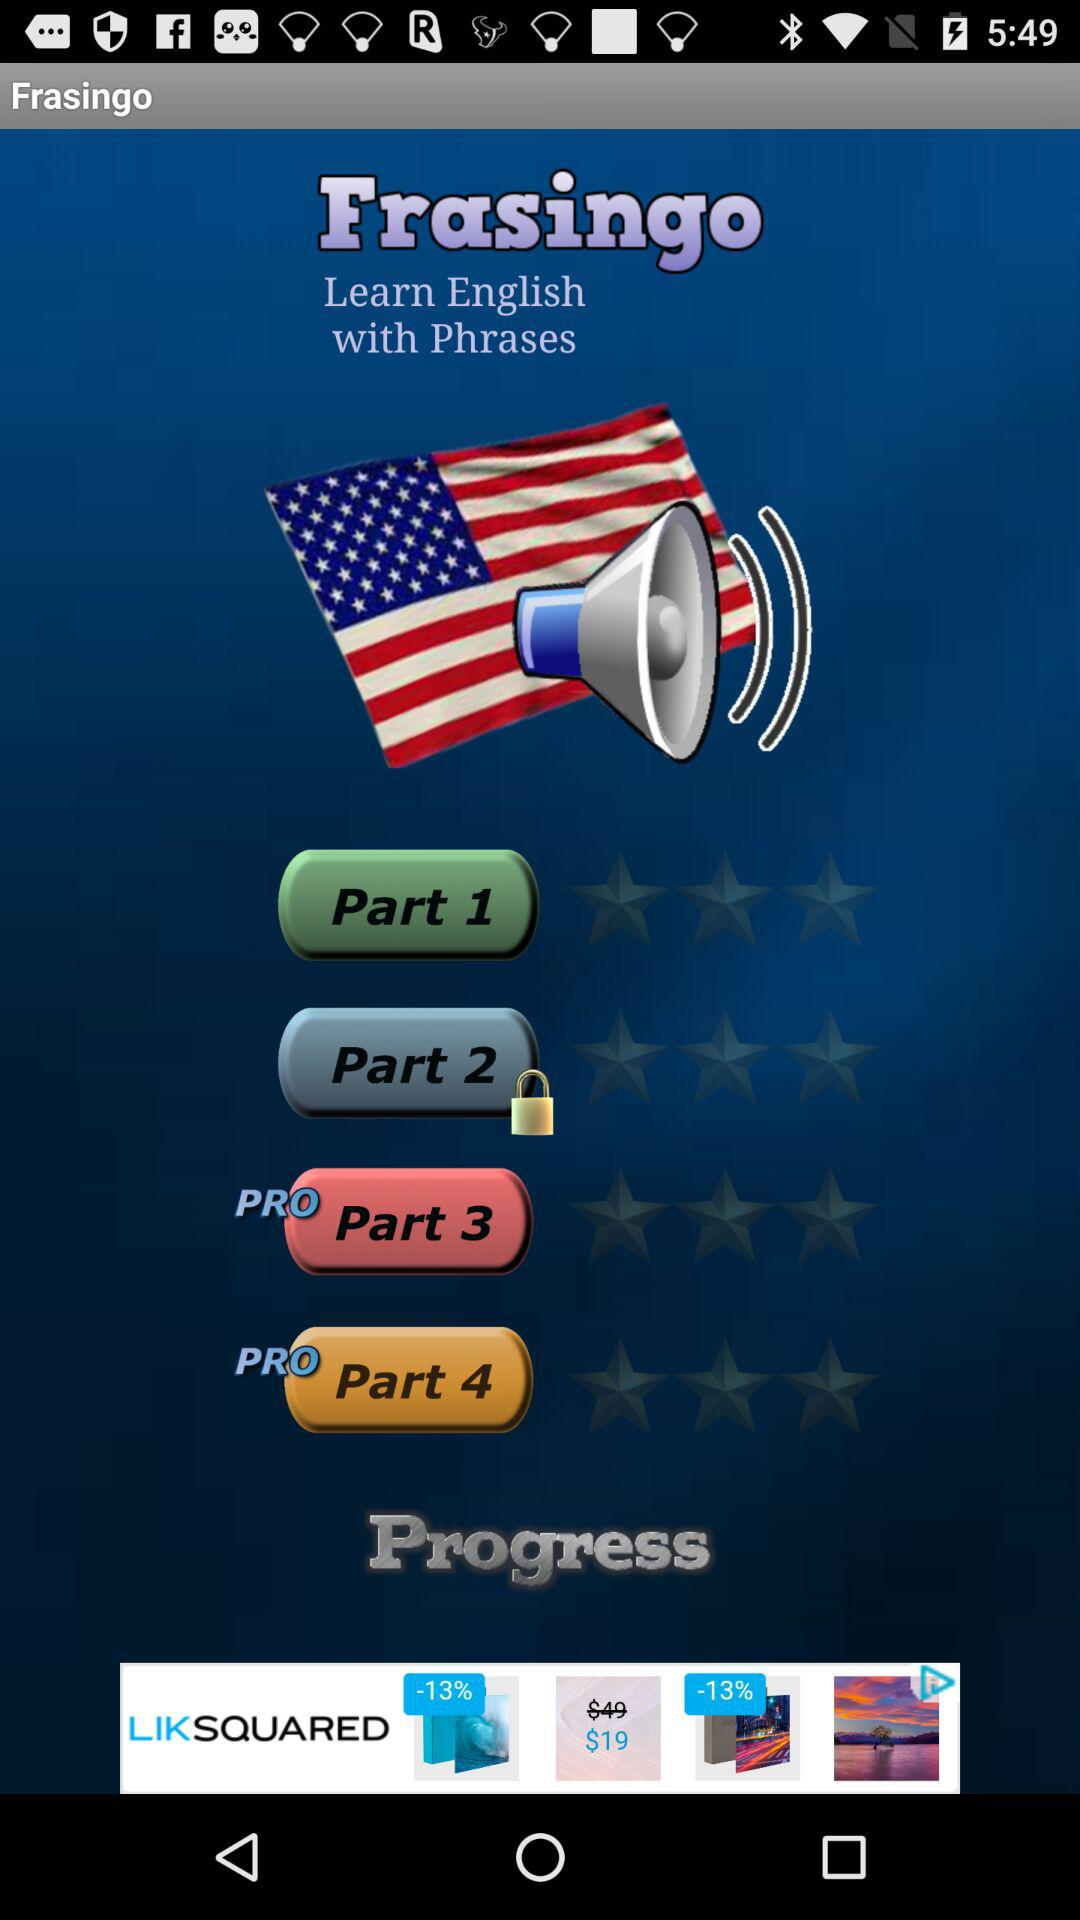What is the name of the application? The name of the application is "Frasingo". 